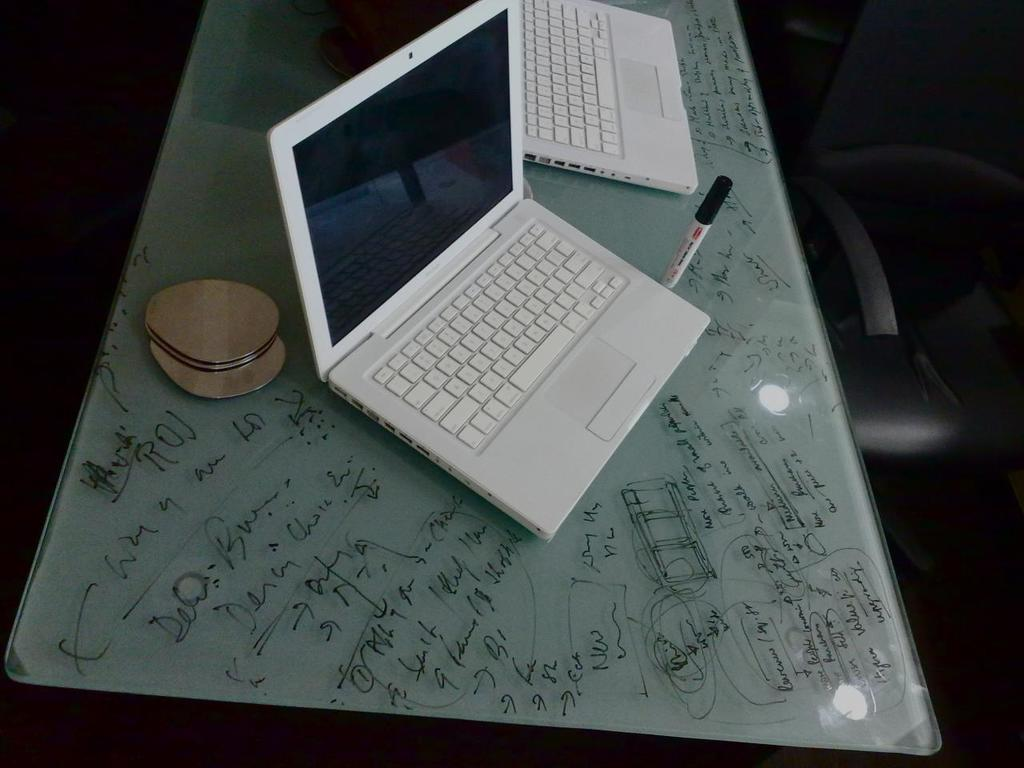What is the main subject in the center of the image? There are laptops and a marker in the center of the image. What is the marker used for? The purpose of the marker is not specified in the image. What is placed on the table? There is an object placed on the table, but its identity is not mentioned in the facts. What can be seen on the right side of the image? There is a chair on the right side of the image. What type of feather can be seen falling on the laptop in the image? There is no feather present in the image. What kind of juice is being poured from the marker in the image? The marker is not associated with any juice in the image. 